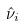Convert formula to latex. <formula><loc_0><loc_0><loc_500><loc_500>\hat { \nu } _ { i }</formula> 